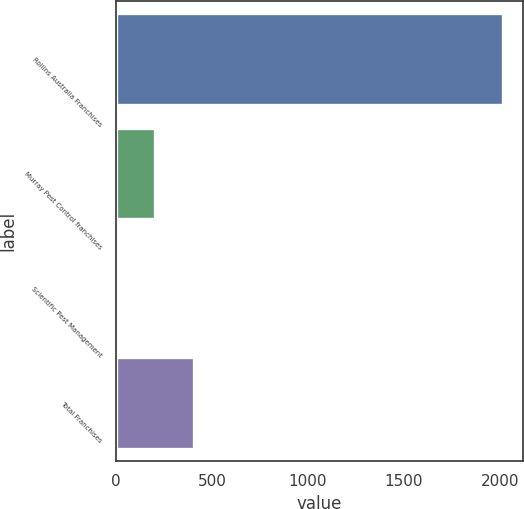Convert chart. <chart><loc_0><loc_0><loc_500><loc_500><bar_chart><fcel>Rollins Australia Franchises<fcel>Murray Pest Control franchises<fcel>Scientific Pest Management<fcel>Total Franchises<nl><fcel>2017<fcel>204.4<fcel>3<fcel>405.8<nl></chart> 